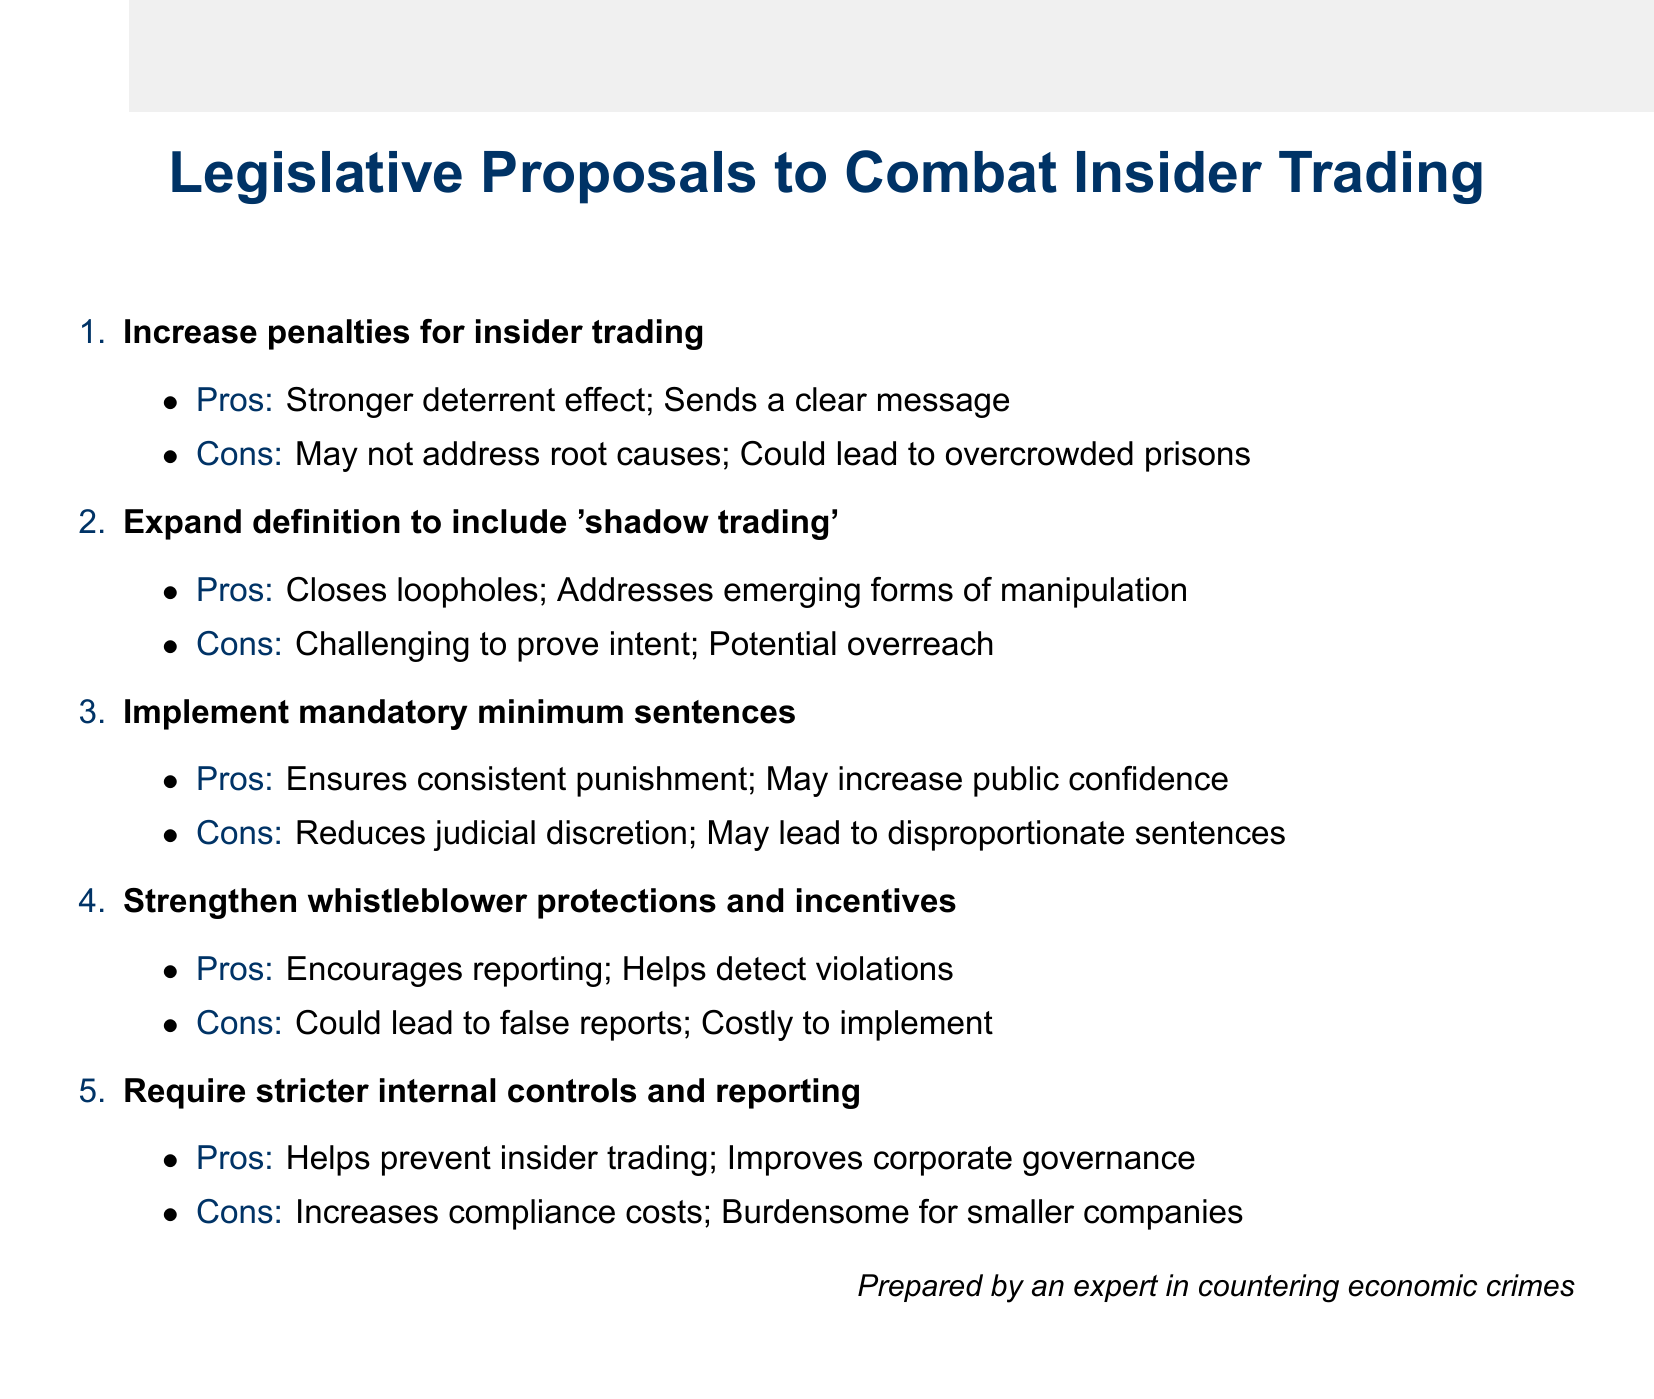What is the first proposal listed to combat insider trading? The first proposal in the document is titled "Increase penalties for insider trading."
Answer: Increase penalties for insider trading What are the pros of implementing mandatory minimum sentences? The document states two pros: consistent punishment across cases and increased public confidence in the justice system.
Answer: Ensures consistent punishment; May increase public confidence What potential issue arises from strengthening whistleblower protections? One con mentioned is that it could lead to false or exaggerated reports, indicating a potential issue with false reporting from whistleblowers.
Answer: Could lead to false or exaggerated reports How many proposals are outlined in the document? The document presents a total of five legislative proposals to combat insider trading.
Answer: Five What is one pro of expanding the definition to include 'shadow trading'? The document indicates that it closes loopholes in current legislation as one of the pros.
Answer: Closes loopholes in current legislation Which proposal addresses corporate governance? The requirement for stricter internal controls and reporting mechanisms specifically aims to improve corporate governance.
Answer: Require stricter internal controls and reporting What is a con related to compliance costs? The proposal requiring stricter internal controls and reporting mechanisms mentions increased compliance costs as a con.
Answer: Increases compliance costs for businesses 